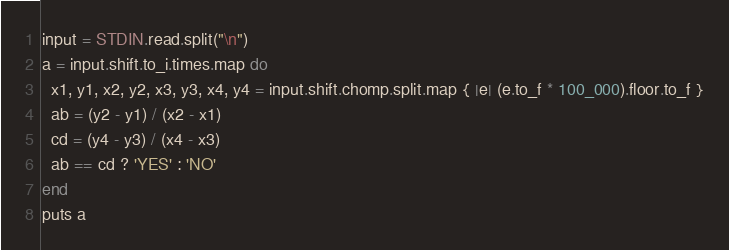<code> <loc_0><loc_0><loc_500><loc_500><_Ruby_>input = STDIN.read.split("\n")
a = input.shift.to_i.times.map do
  x1, y1, x2, y2, x3, y3, x4, y4 = input.shift.chomp.split.map { |e| (e.to_f * 100_000).floor.to_f }
  ab = (y2 - y1) / (x2 - x1)
  cd = (y4 - y3) / (x4 - x3)
  ab == cd ? 'YES' : 'NO'
end
puts a</code> 